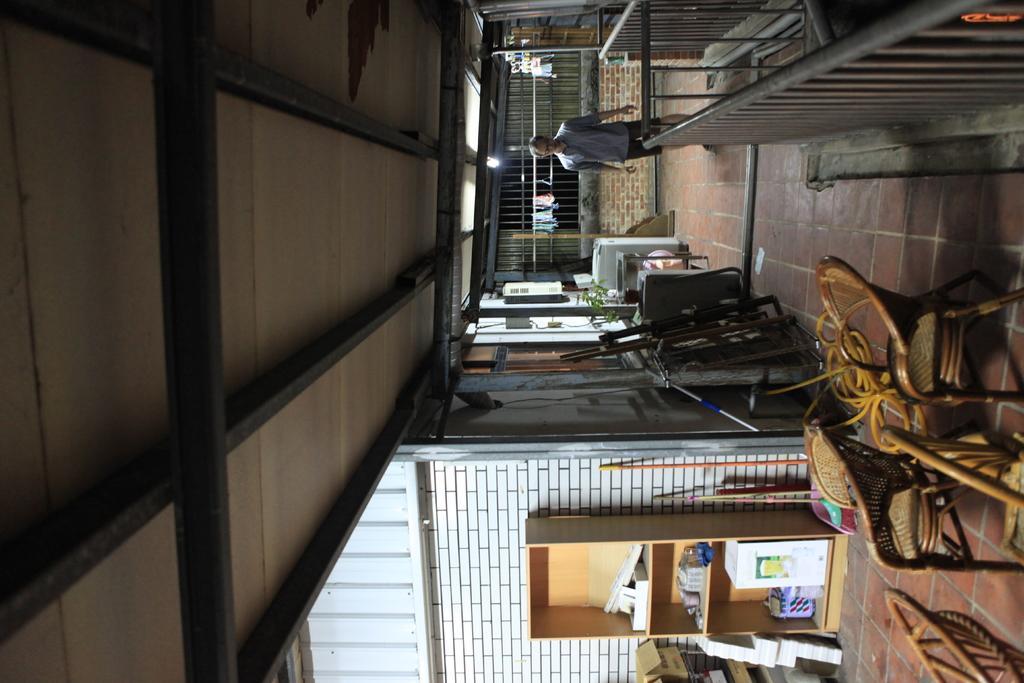Could you give a brief overview of what you see in this image? On the left it is ceiling. In the middle of the picture there are chairs, closet, wall, washing machine, tables, boxes and various objects. At the top right we can see hand railing, person, floor, grills and other objects. 